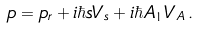<formula> <loc_0><loc_0><loc_500><loc_500>p = p _ { r } + i \hbar { s } V _ { s } + i \hbar { A } _ { 1 } V _ { A } \, .</formula> 